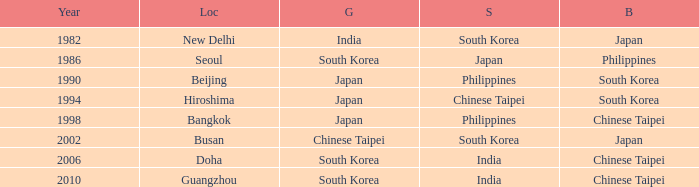Which Year is the highest one that has a Bronze of south korea, and a Silver of philippines? 1990.0. 